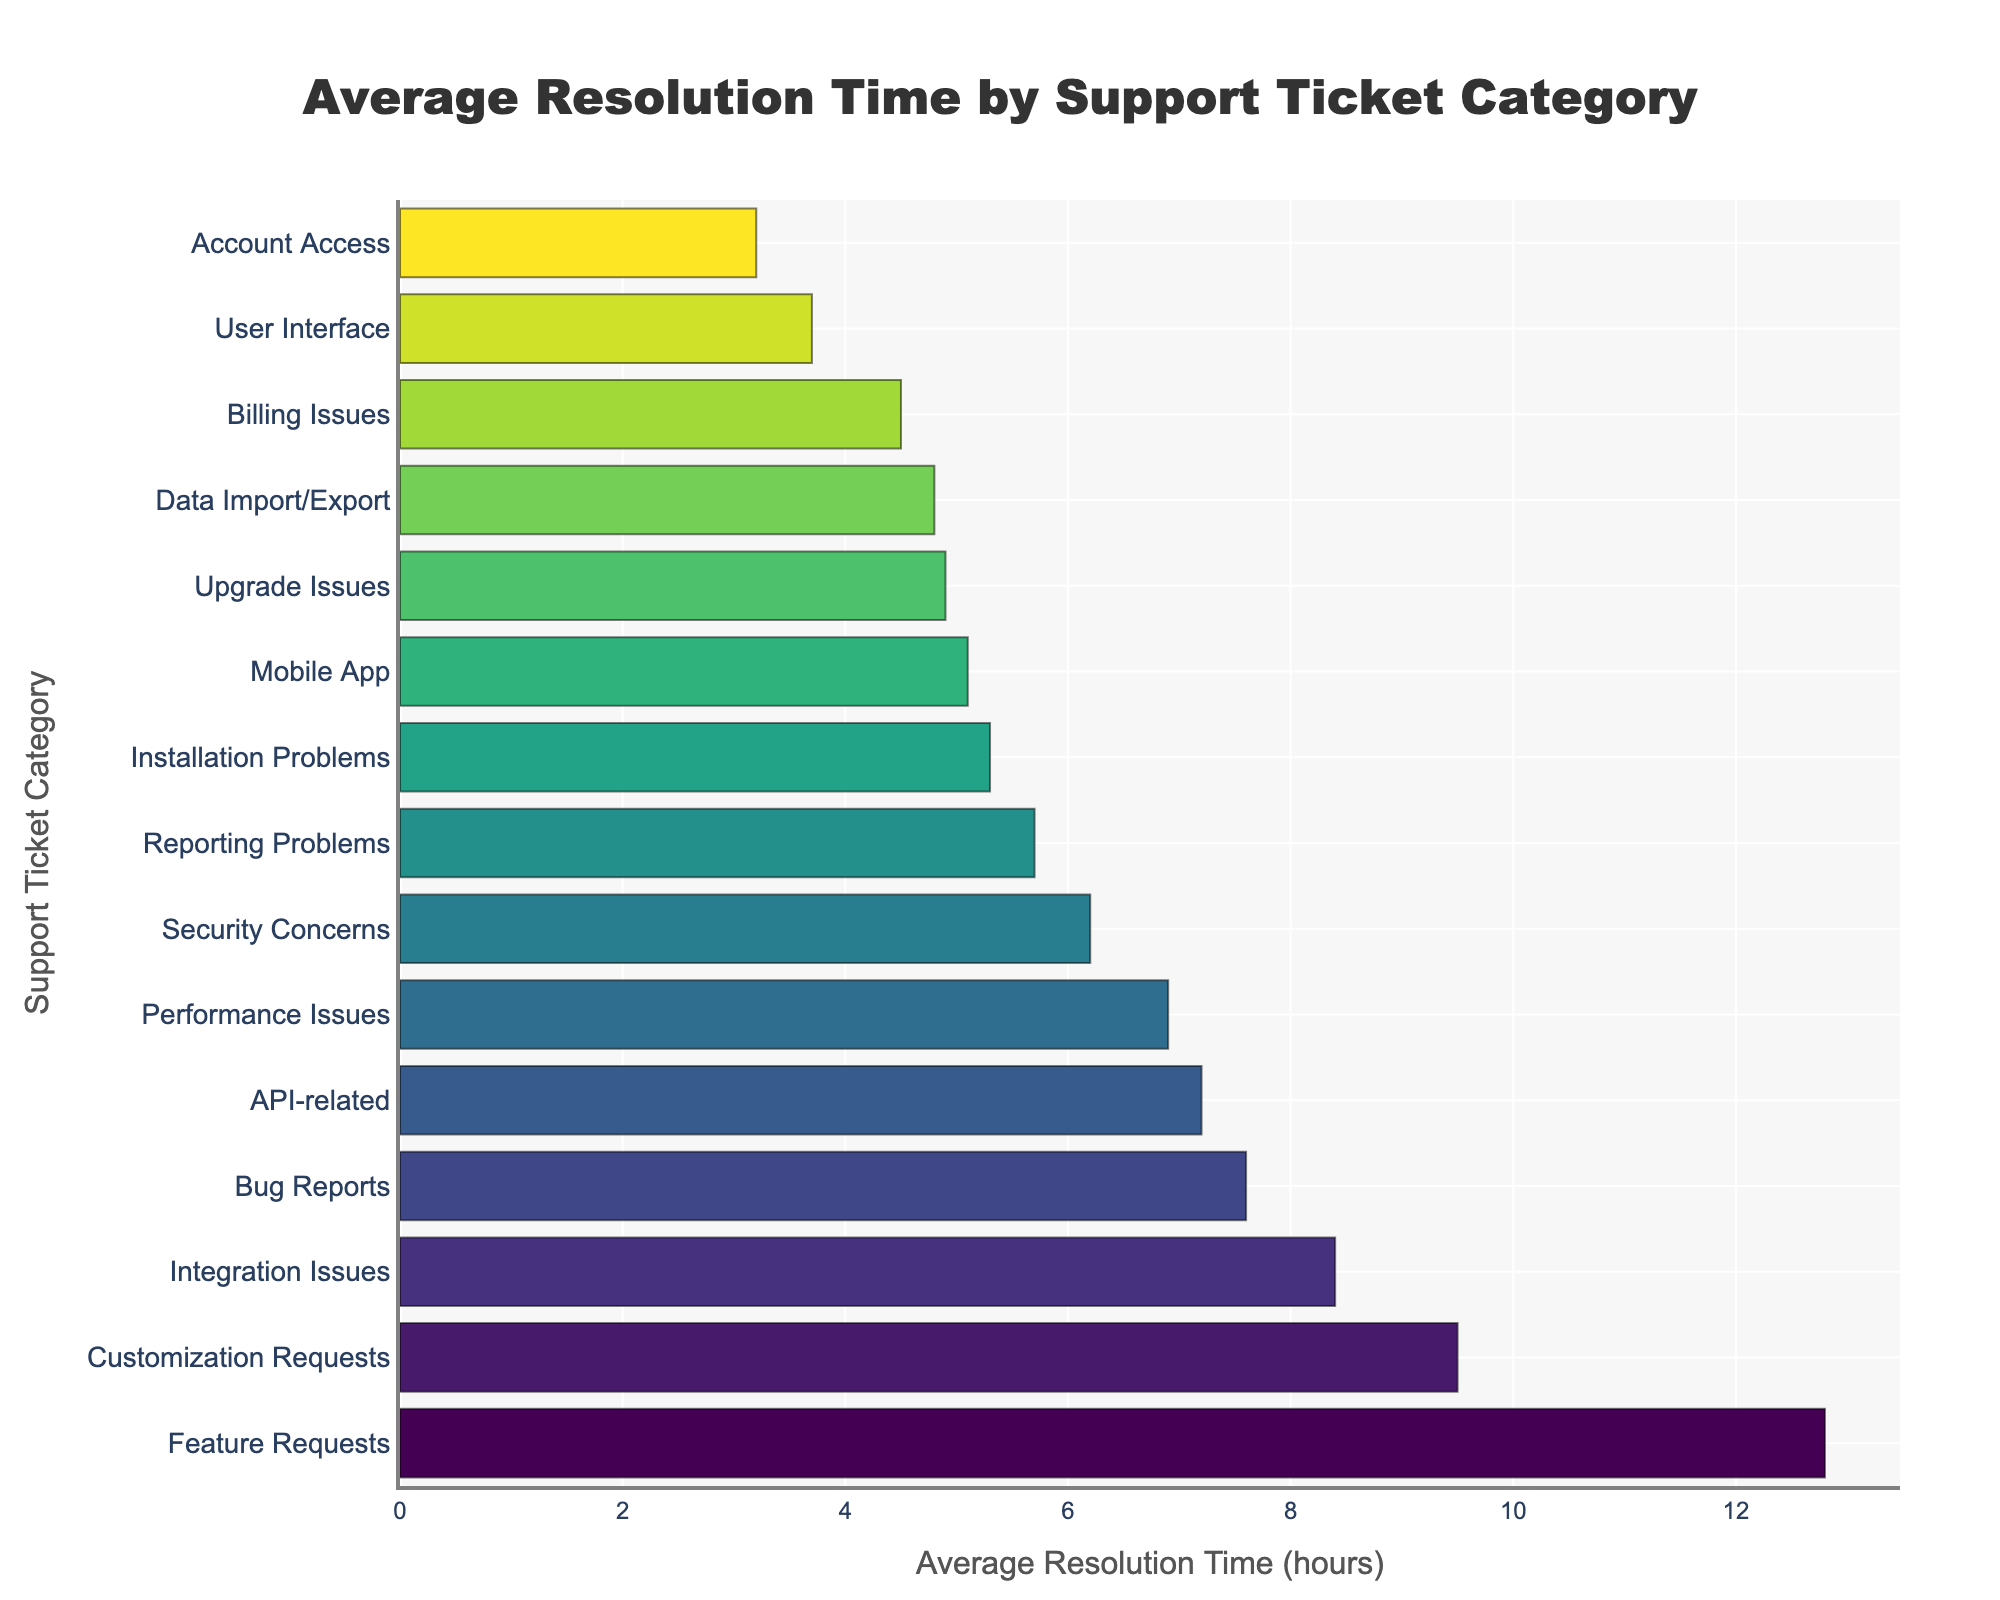Which category has the longest average resolution time? The longest bar in the chart represents the category with the highest average resolution time. By visually inspecting the bar lengths, "Feature Requests" has the longest bar, indicative of the longest average resolution time.
Answer: Feature Requests Which category has the shortest average resolution time? The shortest bar in the chart represents the category with the lowest average resolution time. By visually inspecting the bar lengths, "Account Access" has the shortest bar, indicative of the shortest average resolution time.
Answer: Account Access What is the difference in average resolution time between 'Feature Requests' and 'Account Access'? The average resolution time for 'Feature Requests' is 12.8 hours and for 'Account Access' it is 3.2 hours. Subtracting the two gives 12.8 - 3.2 = 9.6 hours.
Answer: 9.6 hours How many categories have an average resolution time greater than 7 hours? Visually inspect the bars and count those that extend beyond the 7-hour mark on the x-axis. The categories are 'Bug Reports', 'Integration Issues', 'Version Related', 'API-related', 'Customization Requests', and 'Feature Requests'.
Answer: 6 Which two categories have the closest average resolution times, and what are those times? Identify pairs of adjacent bars that are visually closest in length. 'Mobile App' and 'Installation Problems' appear closest, with average resolution times of 5.1 and 5.3 hours, respectively.
Answer: Mobile App (5.1 hours) and Installation Problems (5.3 hours) What is the total average resolution time for 'Bug Reports', 'Integration Issues', and 'Performance Issues'? Summing up the average resolution times: 'Bug Reports' (7.6), 'Integration Issues' (8.4), and 'Performance Issues' (6.9). 7.6 + 8.4 + 6.9 = 22.9 hours.
Answer: 22.9 hours Which category has a slightly higher average resolution time than 'Billing Issues'? 'Billing Issues' has an average resolution time of 4.5 hours. The bar right next to it with a slightly higher resolution time is 'Data Import/Export' with 4.8 hours.
Answer: Data Import/Export How many categories have an average resolution time less than 6 hours? By inspecting the bars that fall below the 6-hour mark on the x-axis, count them: 'Account Access', 'User Interface', 'Billing Issues', 'Data Import/Export', 'Mobile App', 'Installation Problems', 'Reporting Problems', and 'Upgrade Issues'.
Answer: 8 Compare the average resolution times for 'Security Concerns' and 'User Interface' concerns. Which is longer? 'Security Concerns' has an average resolution time of 6.2 hours, whereas 'User Interface' has 3.7 hours. Therefore, 'Security Concerns' has a longer average resolution time.
Answer: Security Concerns 